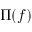Convert formula to latex. <formula><loc_0><loc_0><loc_500><loc_500>\Pi ( f )</formula> 